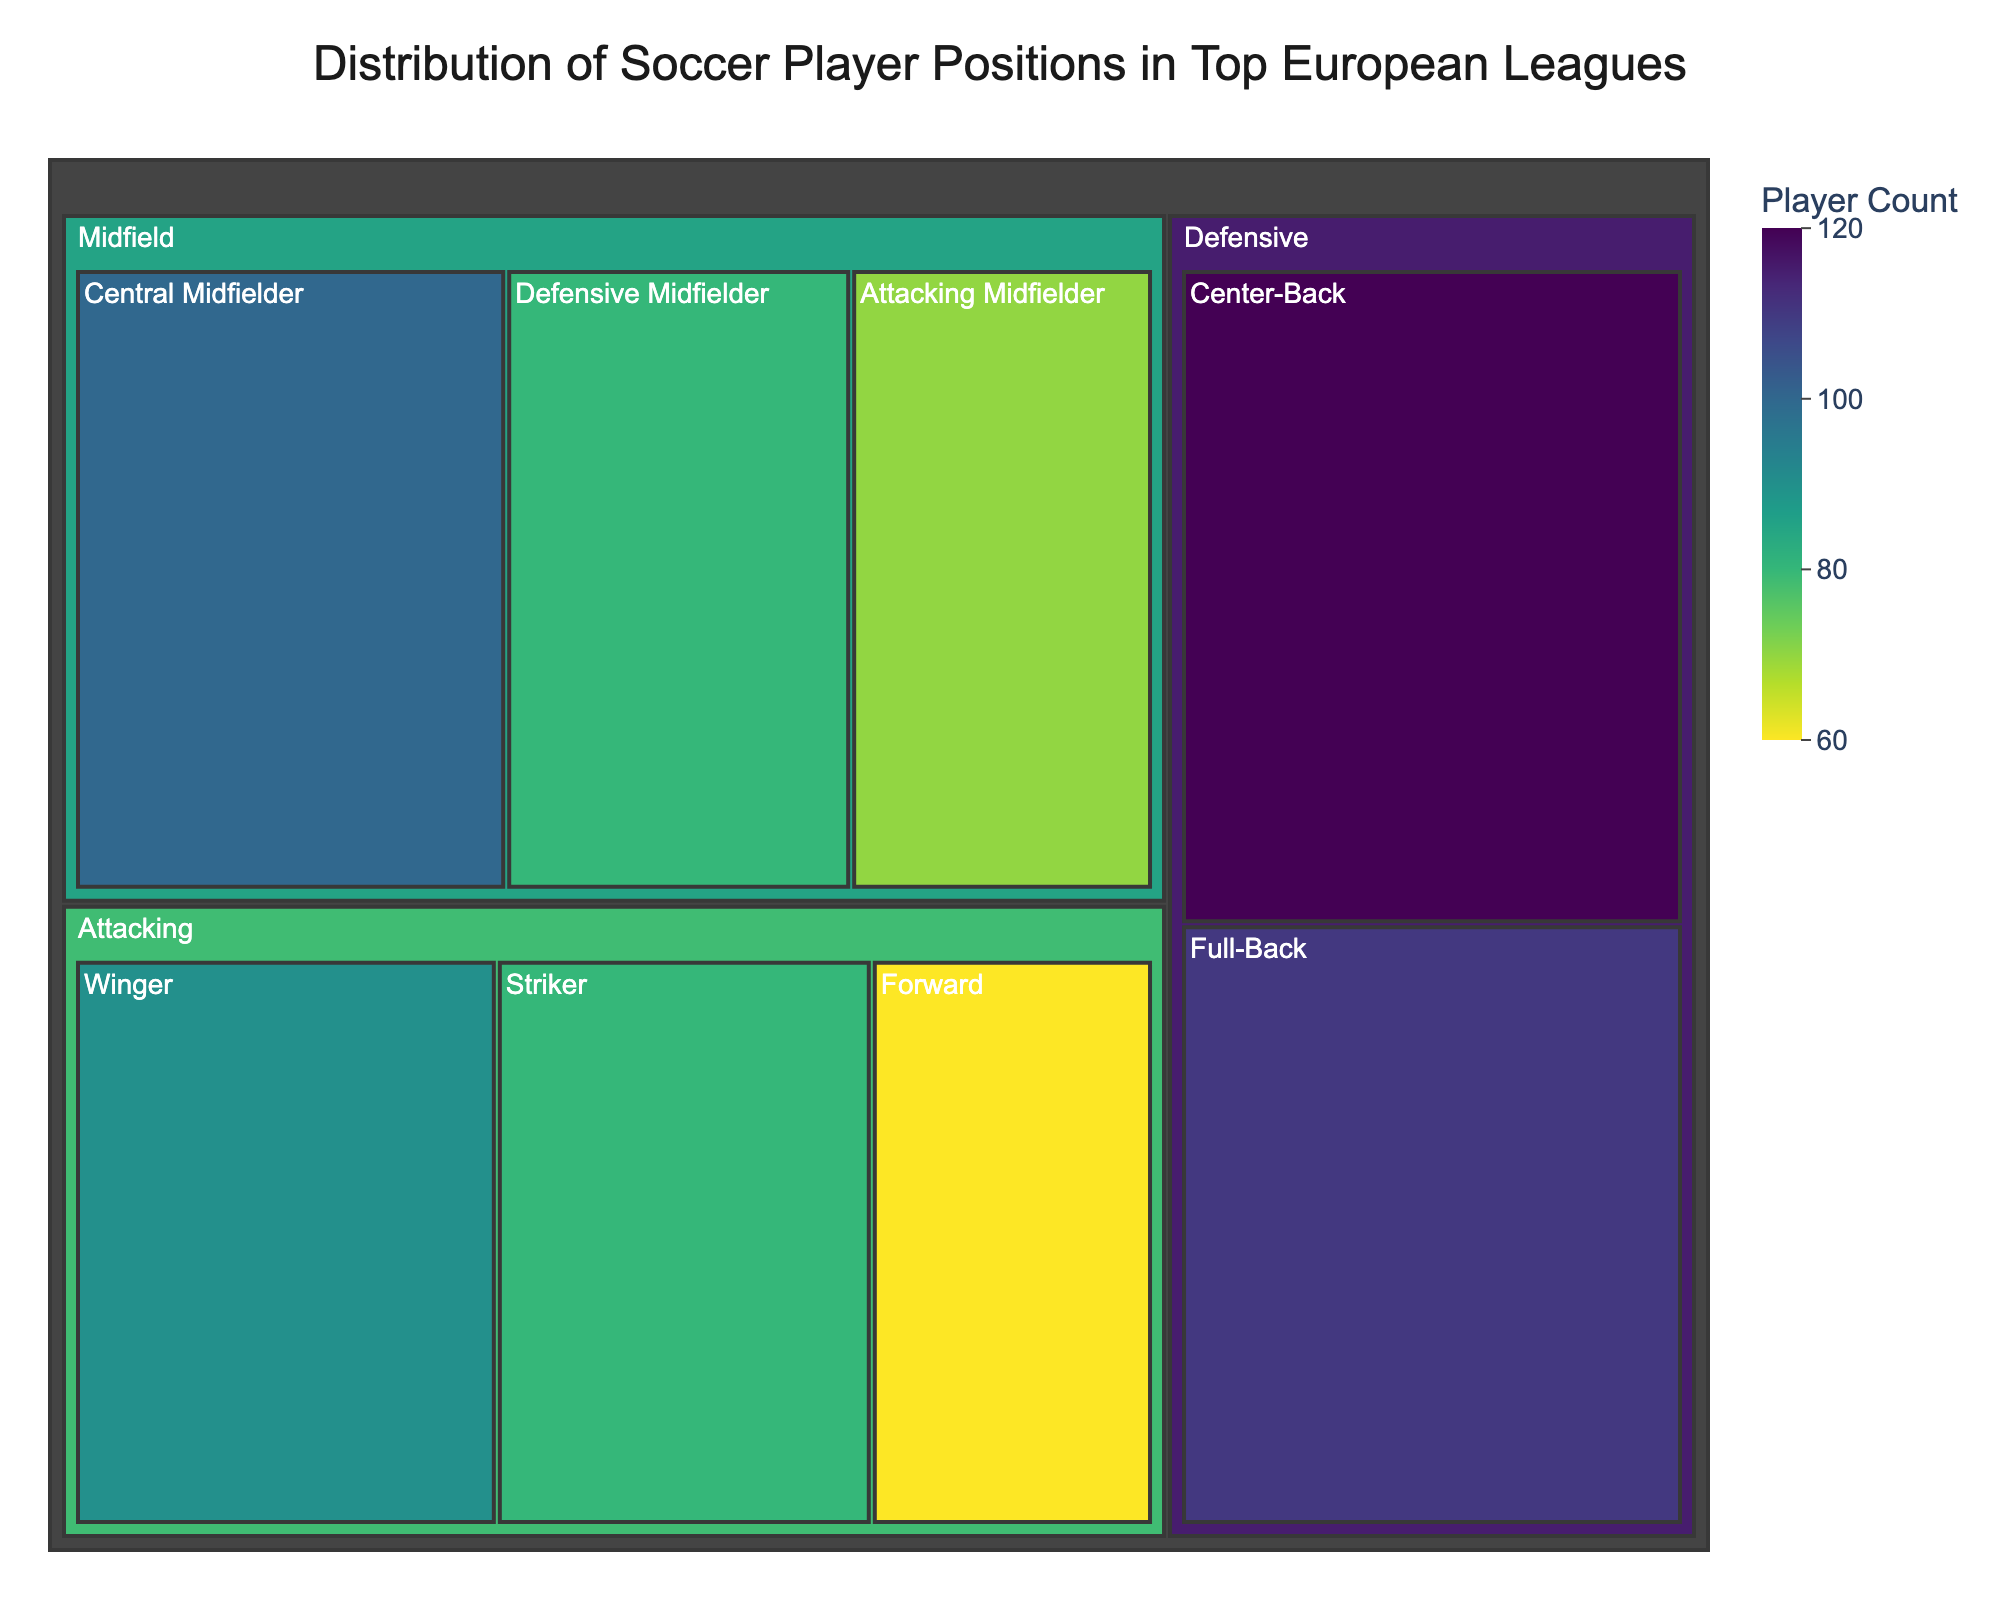question explanation
Answer: concise answer What is the title of the figure? The title is usually the most prominent text at the top of the figure.
Answer: Distribution of Soccer Player Positions in Top European Leagues Which category has the highest number of players? The category with the largest combined area in the treemap indicates the highest number.
Answer: Defensive How many player positions are categorized under Attacking? Count the number of distinct positions listed under the 'Attacking' category.
Answer: 3 What is the count of Central Midfielders? Locate the 'Central Midfielder' in the tree map and check its count value.
Answer: 100 What is the total number of players in the Midfield category? Sum the player counts for all positions under Midfield: Defensive Midfielder, Central Midfielder, and Attacking Midfielder. 80 + 100 + 70 = 250
Answer: 250 What is the difference in count between Full-Backs and Strikers? Subtract the number of Strikers from the number of Full-Backs. 110 - 80 = 30
Answer: 30 Which has more players, Wingers or Forwards? Compare the count of players in the Winger position to those in the Forward position.
Answer: Wingers Is the number of Forward players greater than Defensive Midfielders? Compare the number of players in the Forward position to those in the Defensive Midfielder position.
Answer: No What is the combined count of Strikers and Forwards in the Attacking category? Add the number of Strikers to the number of Forwards. 80 + 60 = 140
Answer: 140 Which defensive position has fewer players, Full-Backs or Center-Backs? Compare the count of Full-Backs to Center-Backs.
Answer: Full-Backs 